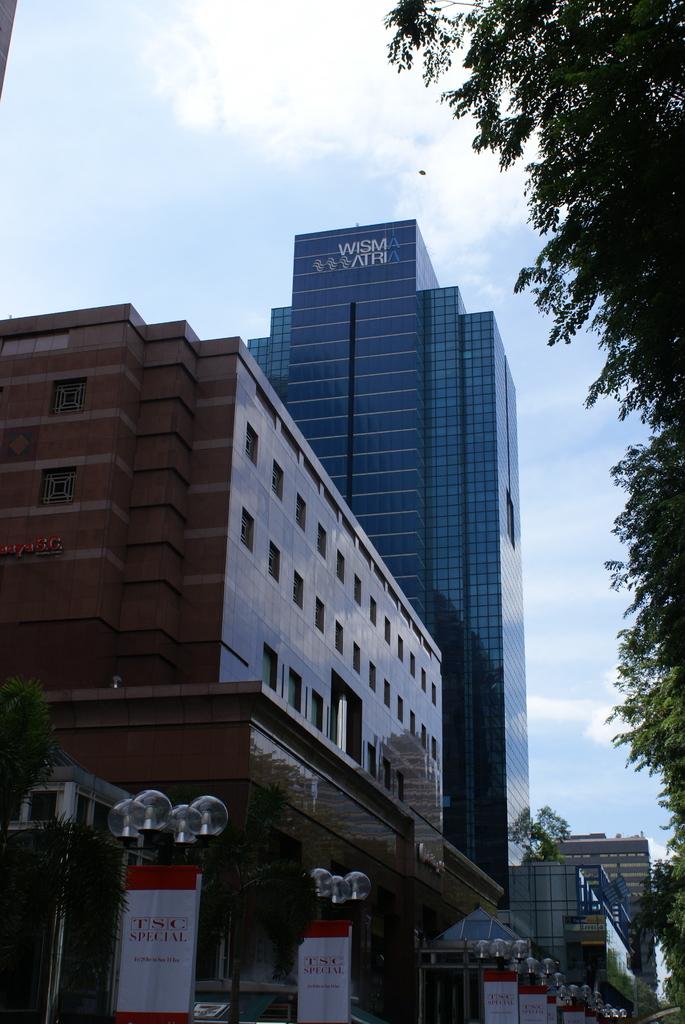Which company is the taller skyscraper featuring?
Your answer should be compact. Wisma atria. Is this outside?
Ensure brevity in your answer.  Answering does not require reading text in the image. 